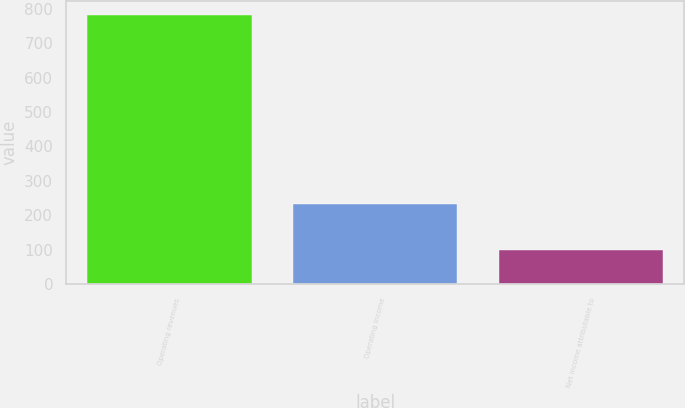Convert chart to OTSL. <chart><loc_0><loc_0><loc_500><loc_500><bar_chart><fcel>Operating revenues<fcel>Operating income<fcel>Net income attributable to<nl><fcel>783<fcel>232<fcel>99<nl></chart> 